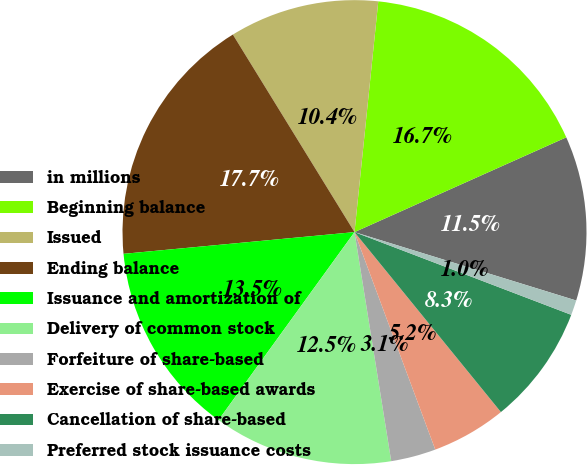Convert chart. <chart><loc_0><loc_0><loc_500><loc_500><pie_chart><fcel>in millions<fcel>Beginning balance<fcel>Issued<fcel>Ending balance<fcel>Issuance and amortization of<fcel>Delivery of common stock<fcel>Forfeiture of share-based<fcel>Exercise of share-based awards<fcel>Cancellation of share-based<fcel>Preferred stock issuance costs<nl><fcel>11.46%<fcel>16.67%<fcel>10.42%<fcel>17.71%<fcel>13.54%<fcel>12.5%<fcel>3.13%<fcel>5.21%<fcel>8.33%<fcel>1.04%<nl></chart> 